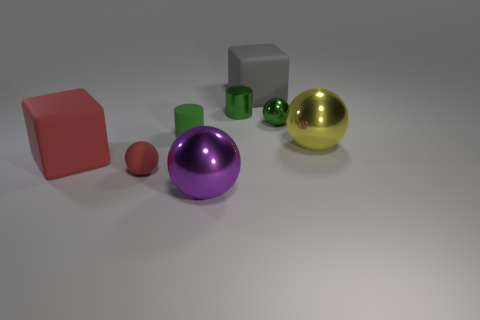Add 1 large cylinders. How many objects exist? 9 Subtract all cylinders. How many objects are left? 6 Add 4 shiny things. How many shiny things exist? 8 Subtract 1 gray blocks. How many objects are left? 7 Subtract all big blue shiny things. Subtract all red objects. How many objects are left? 6 Add 2 blocks. How many blocks are left? 4 